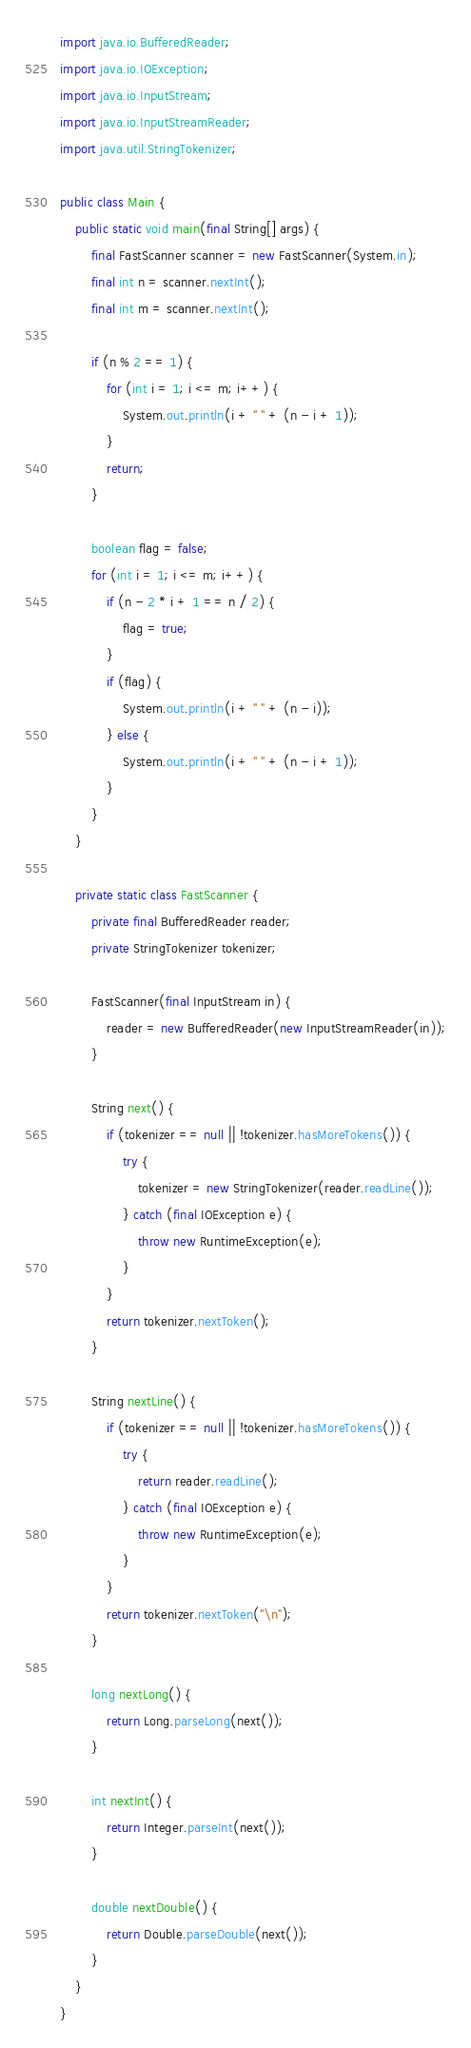Convert code to text. <code><loc_0><loc_0><loc_500><loc_500><_Java_>
import java.io.BufferedReader;
import java.io.IOException;
import java.io.InputStream;
import java.io.InputStreamReader;
import java.util.StringTokenizer;

public class Main {
    public static void main(final String[] args) {
        final FastScanner scanner = new FastScanner(System.in);
        final int n = scanner.nextInt();
        final int m = scanner.nextInt();

        if (n % 2 == 1) {
            for (int i = 1; i <= m; i++) {
                System.out.println(i + " " + (n - i + 1));
            }
            return;
        }

        boolean flag = false;
        for (int i = 1; i <= m; i++) {
            if (n - 2 * i + 1 == n / 2) {
                flag = true;
            }
            if (flag) {
                System.out.println(i + " " + (n - i));
            } else {
                System.out.println(i + " " + (n - i + 1));
            }
        }
    }

    private static class FastScanner {
        private final BufferedReader reader;
        private StringTokenizer tokenizer;

        FastScanner(final InputStream in) {
            reader = new BufferedReader(new InputStreamReader(in));
        }

        String next() {
            if (tokenizer == null || !tokenizer.hasMoreTokens()) {
                try {
                    tokenizer = new StringTokenizer(reader.readLine());
                } catch (final IOException e) {
                    throw new RuntimeException(e);
                }
            }
            return tokenizer.nextToken();
        }

        String nextLine() {
            if (tokenizer == null || !tokenizer.hasMoreTokens()) {
                try {
                    return reader.readLine();
                } catch (final IOException e) {
                    throw new RuntimeException(e);
                }
            }
            return tokenizer.nextToken("\n");
        }

        long nextLong() {
            return Long.parseLong(next());
        }

        int nextInt() {
            return Integer.parseInt(next());
        }

        double nextDouble() {
            return Double.parseDouble(next());
        }
    }
}
</code> 